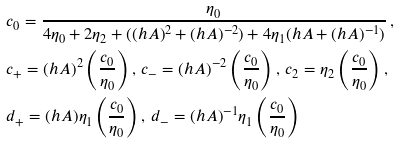<formula> <loc_0><loc_0><loc_500><loc_500>& c _ { 0 } = \frac { \eta _ { 0 } } { 4 \eta _ { 0 } + 2 \eta _ { 2 } + ( ( h A ) ^ { 2 } + ( h A ) ^ { - 2 } ) + 4 \eta _ { 1 } ( h A + ( h A ) ^ { - 1 } ) } \, , \\ & c _ { + } = ( h A ) ^ { 2 } \left ( \frac { c _ { 0 } } { \eta _ { 0 } } \right ) , \, c _ { - } = ( h A ) ^ { - 2 } \left ( \frac { c _ { 0 } } { \eta _ { 0 } } \right ) , \, c _ { 2 } = \eta _ { 2 } \left ( \frac { c _ { 0 } } { \eta _ { 0 } } \right ) , \\ & d _ { + } = ( h A ) \eta _ { 1 } \left ( \frac { c _ { 0 } } { \eta _ { 0 } } \right ) , \, d _ { - } = ( h A ) ^ { - 1 } \eta _ { 1 } \left ( \frac { c _ { 0 } } { \eta _ { 0 } } \right )</formula> 